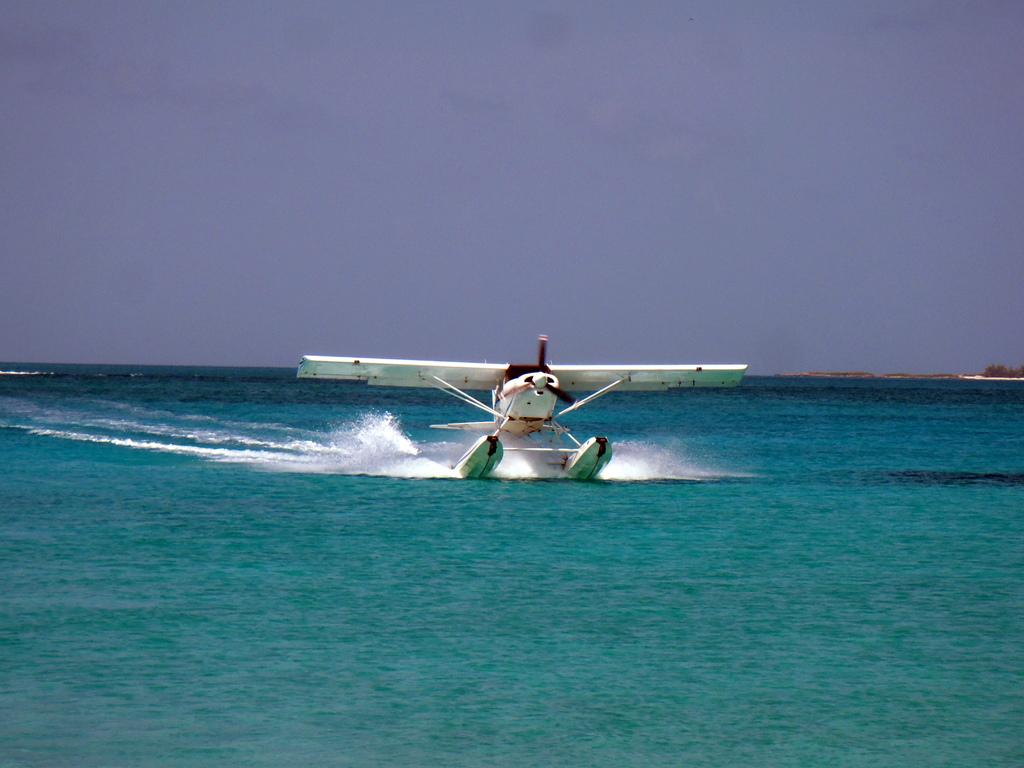What is present in the image that is not on the ground? The sky is visible in the image. What type of vehicle can be seen in the image? There is a helicopter in the image. What natural element is present in the image? Water is visible in the image. What time is displayed on the desk clock in the image? There is no desk or clock present in the image, so we cannot determine the time. 